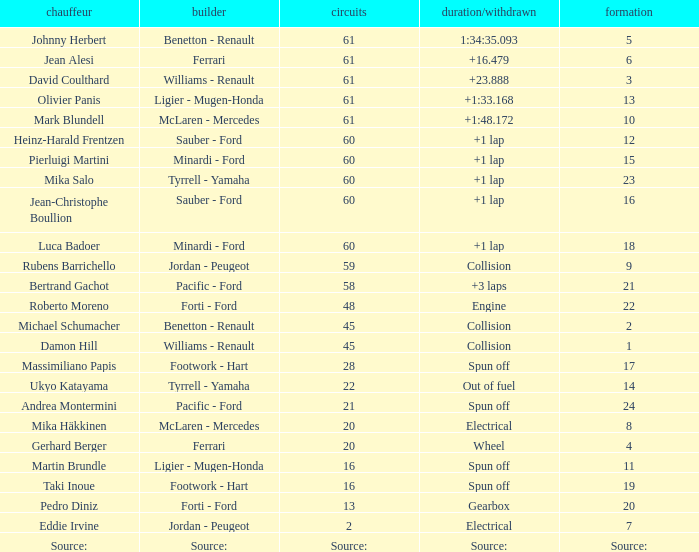How many laps does roberto moreno have? 48.0. 